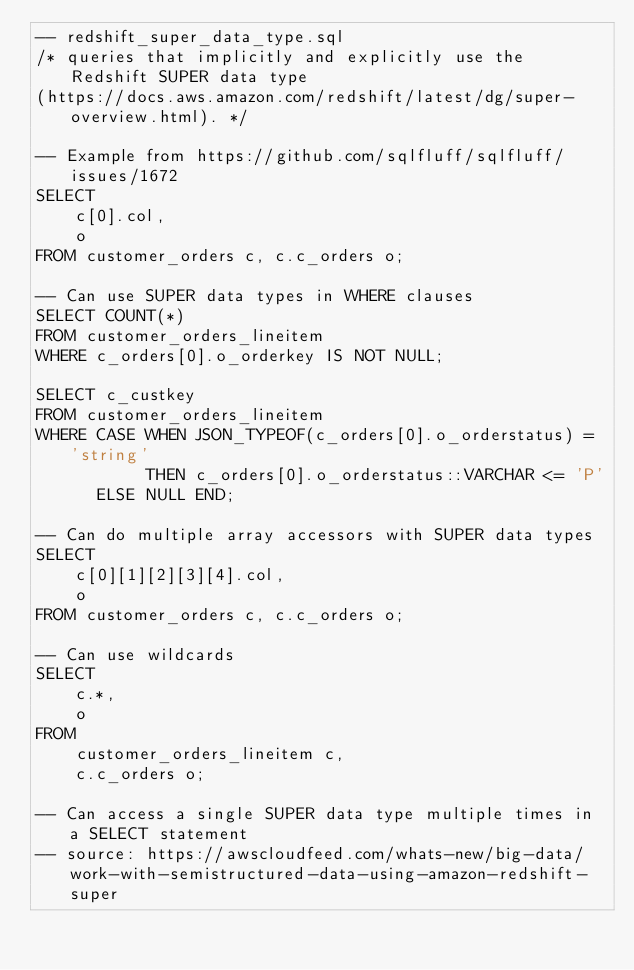Convert code to text. <code><loc_0><loc_0><loc_500><loc_500><_SQL_>-- redshift_super_data_type.sql
/* queries that implicitly and explicitly use the Redshift SUPER data type
(https://docs.aws.amazon.com/redshift/latest/dg/super-overview.html). */

-- Example from https://github.com/sqlfluff/sqlfluff/issues/1672
SELECT
    c[0].col,
    o
FROM customer_orders c, c.c_orders o;

-- Can use SUPER data types in WHERE clauses
SELECT COUNT(*)
FROM customer_orders_lineitem
WHERE c_orders[0].o_orderkey IS NOT NULL;

SELECT c_custkey
FROM customer_orders_lineitem
WHERE CASE WHEN JSON_TYPEOF(c_orders[0].o_orderstatus) = 'string'
           THEN c_orders[0].o_orderstatus::VARCHAR <= 'P'
      ELSE NULL END;

-- Can do multiple array accessors with SUPER data types
SELECT
    c[0][1][2][3][4].col,
    o
FROM customer_orders c, c.c_orders o;

-- Can use wildcards
SELECT
    c.*,
    o
FROM
    customer_orders_lineitem c,
    c.c_orders o;

-- Can access a single SUPER data type multiple times in a SELECT statement
-- source: https://awscloudfeed.com/whats-new/big-data/work-with-semistructured-data-using-amazon-redshift-super</code> 